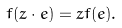<formula> <loc_0><loc_0><loc_500><loc_500>f ( z \cdot e ) = z f ( e ) .</formula> 